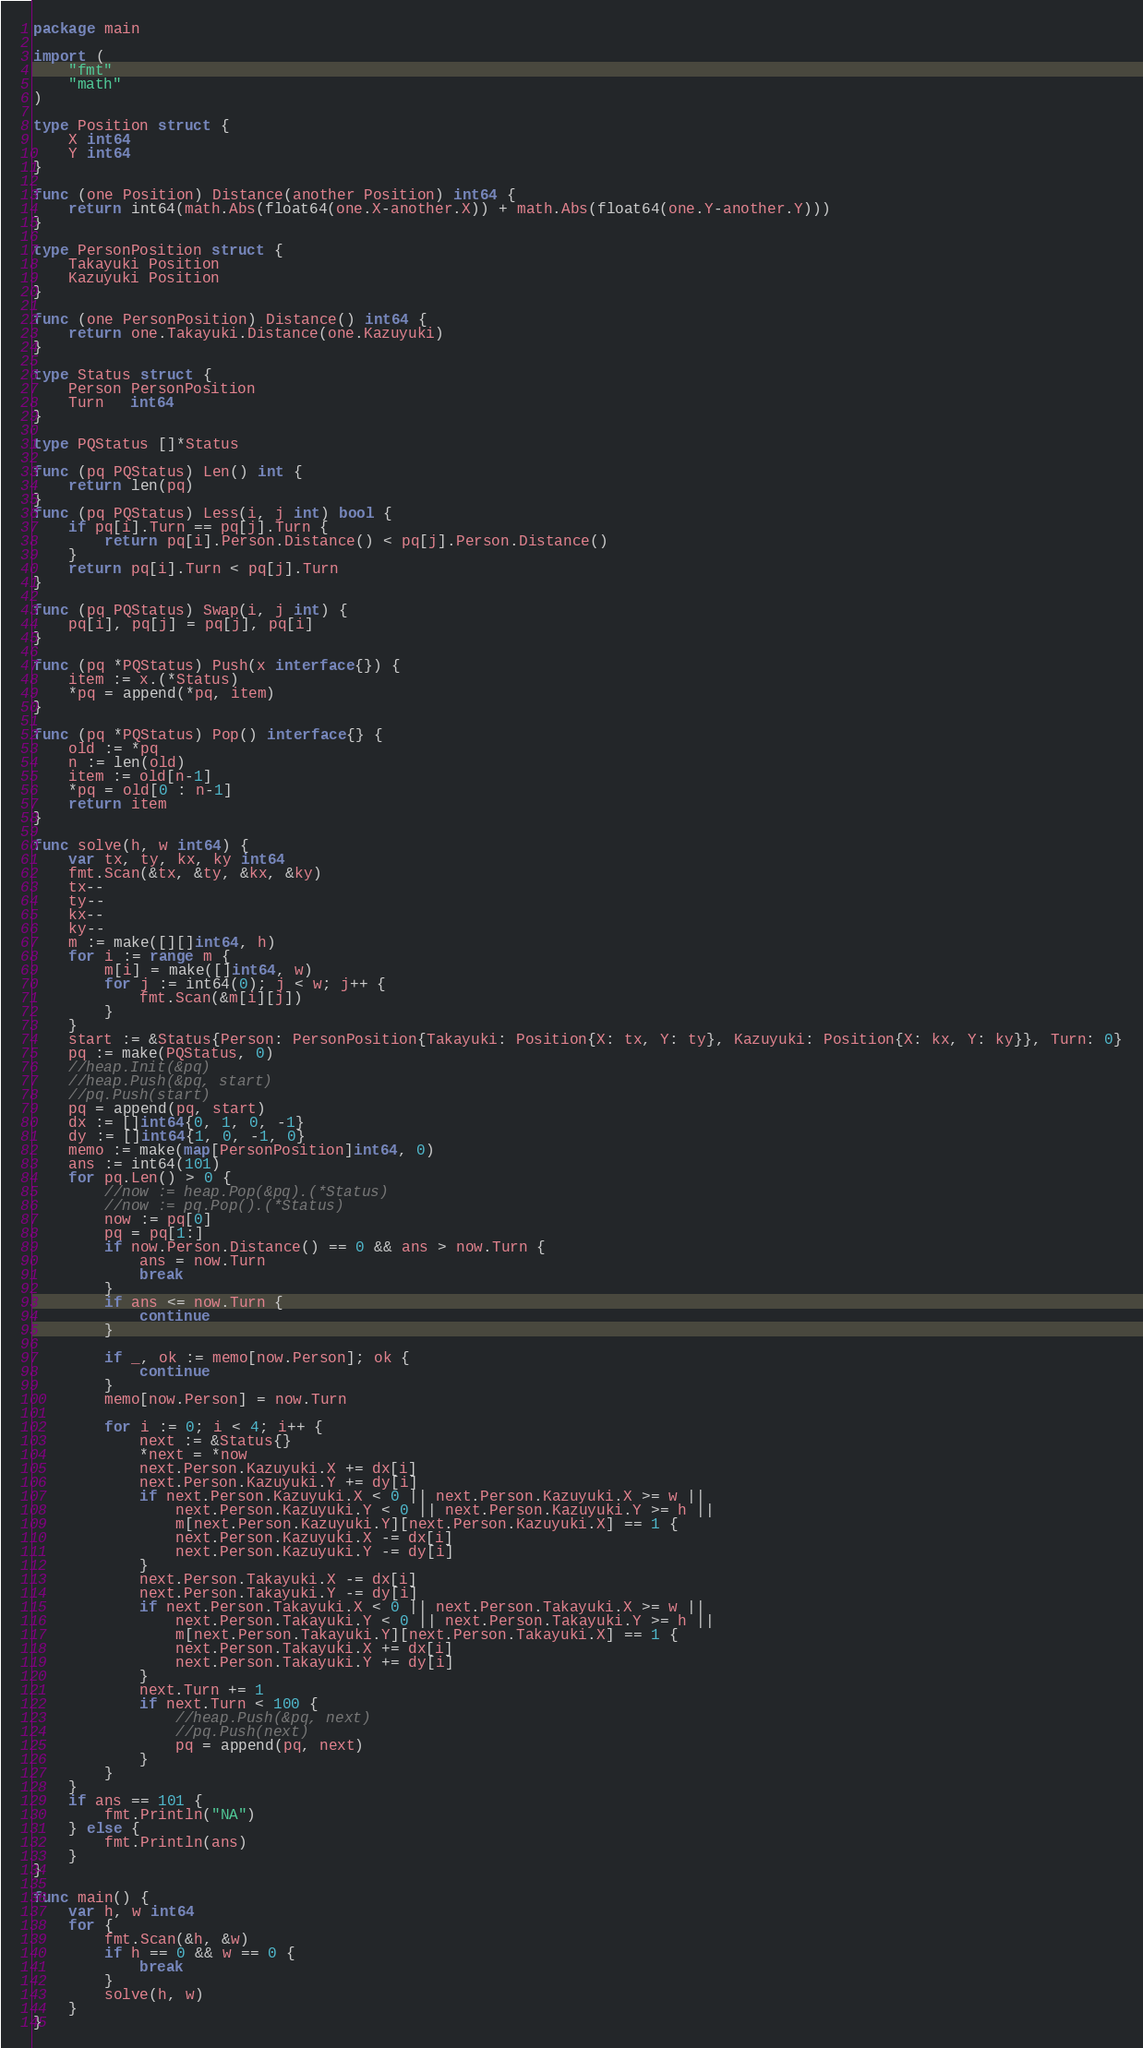Convert code to text. <code><loc_0><loc_0><loc_500><loc_500><_Go_>package main

import (
	"fmt"
	"math"
)

type Position struct {
	X int64
	Y int64
}

func (one Position) Distance(another Position) int64 {
	return int64(math.Abs(float64(one.X-another.X)) + math.Abs(float64(one.Y-another.Y)))
}

type PersonPosition struct {
	Takayuki Position
	Kazuyuki Position
}

func (one PersonPosition) Distance() int64 {
	return one.Takayuki.Distance(one.Kazuyuki)
}

type Status struct {
	Person PersonPosition
	Turn   int64
}

type PQStatus []*Status

func (pq PQStatus) Len() int {
	return len(pq)
}
func (pq PQStatus) Less(i, j int) bool {
	if pq[i].Turn == pq[j].Turn {
		return pq[i].Person.Distance() < pq[j].Person.Distance()
	}
	return pq[i].Turn < pq[j].Turn
}

func (pq PQStatus) Swap(i, j int) {
	pq[i], pq[j] = pq[j], pq[i]
}

func (pq *PQStatus) Push(x interface{}) {
	item := x.(*Status)
	*pq = append(*pq, item)
}

func (pq *PQStatus) Pop() interface{} {
	old := *pq
	n := len(old)
	item := old[n-1]
	*pq = old[0 : n-1]
	return item
}

func solve(h, w int64) {
	var tx, ty, kx, ky int64
	fmt.Scan(&tx, &ty, &kx, &ky)
	tx--
	ty--
	kx--
	ky--
	m := make([][]int64, h)
	for i := range m {
		m[i] = make([]int64, w)
		for j := int64(0); j < w; j++ {
			fmt.Scan(&m[i][j])
		}
	}
	start := &Status{Person: PersonPosition{Takayuki: Position{X: tx, Y: ty}, Kazuyuki: Position{X: kx, Y: ky}}, Turn: 0}
	pq := make(PQStatus, 0)
	//heap.Init(&pq)
	//heap.Push(&pq, start)
	//pq.Push(start)
	pq = append(pq, start)
	dx := []int64{0, 1, 0, -1}
	dy := []int64{1, 0, -1, 0}
	memo := make(map[PersonPosition]int64, 0)
	ans := int64(101)
	for pq.Len() > 0 {
		//now := heap.Pop(&pq).(*Status)
		//now := pq.Pop().(*Status)
		now := pq[0]
		pq = pq[1:]
		if now.Person.Distance() == 0 && ans > now.Turn {
			ans = now.Turn
			break
		}
		if ans <= now.Turn {
			continue
		}

		if _, ok := memo[now.Person]; ok {
			continue
		}
		memo[now.Person] = now.Turn

		for i := 0; i < 4; i++ {
			next := &Status{}
			*next = *now
			next.Person.Kazuyuki.X += dx[i]
			next.Person.Kazuyuki.Y += dy[i]
			if next.Person.Kazuyuki.X < 0 || next.Person.Kazuyuki.X >= w ||
				next.Person.Kazuyuki.Y < 0 || next.Person.Kazuyuki.Y >= h ||
				m[next.Person.Kazuyuki.Y][next.Person.Kazuyuki.X] == 1 {
				next.Person.Kazuyuki.X -= dx[i]
				next.Person.Kazuyuki.Y -= dy[i]
			}
			next.Person.Takayuki.X -= dx[i]
			next.Person.Takayuki.Y -= dy[i]
			if next.Person.Takayuki.X < 0 || next.Person.Takayuki.X >= w ||
				next.Person.Takayuki.Y < 0 || next.Person.Takayuki.Y >= h ||
				m[next.Person.Takayuki.Y][next.Person.Takayuki.X] == 1 {
				next.Person.Takayuki.X += dx[i]
				next.Person.Takayuki.Y += dy[i]
			}
			next.Turn += 1
			if next.Turn < 100 {
				//heap.Push(&pq, next)
				//pq.Push(next)
				pq = append(pq, next)
			}
		}
	}
	if ans == 101 {
		fmt.Println("NA")
	} else {
		fmt.Println(ans)
	}
}

func main() {
	var h, w int64
	for {
		fmt.Scan(&h, &w)
		if h == 0 && w == 0 {
			break
		}
		solve(h, w)
	}
}

</code> 